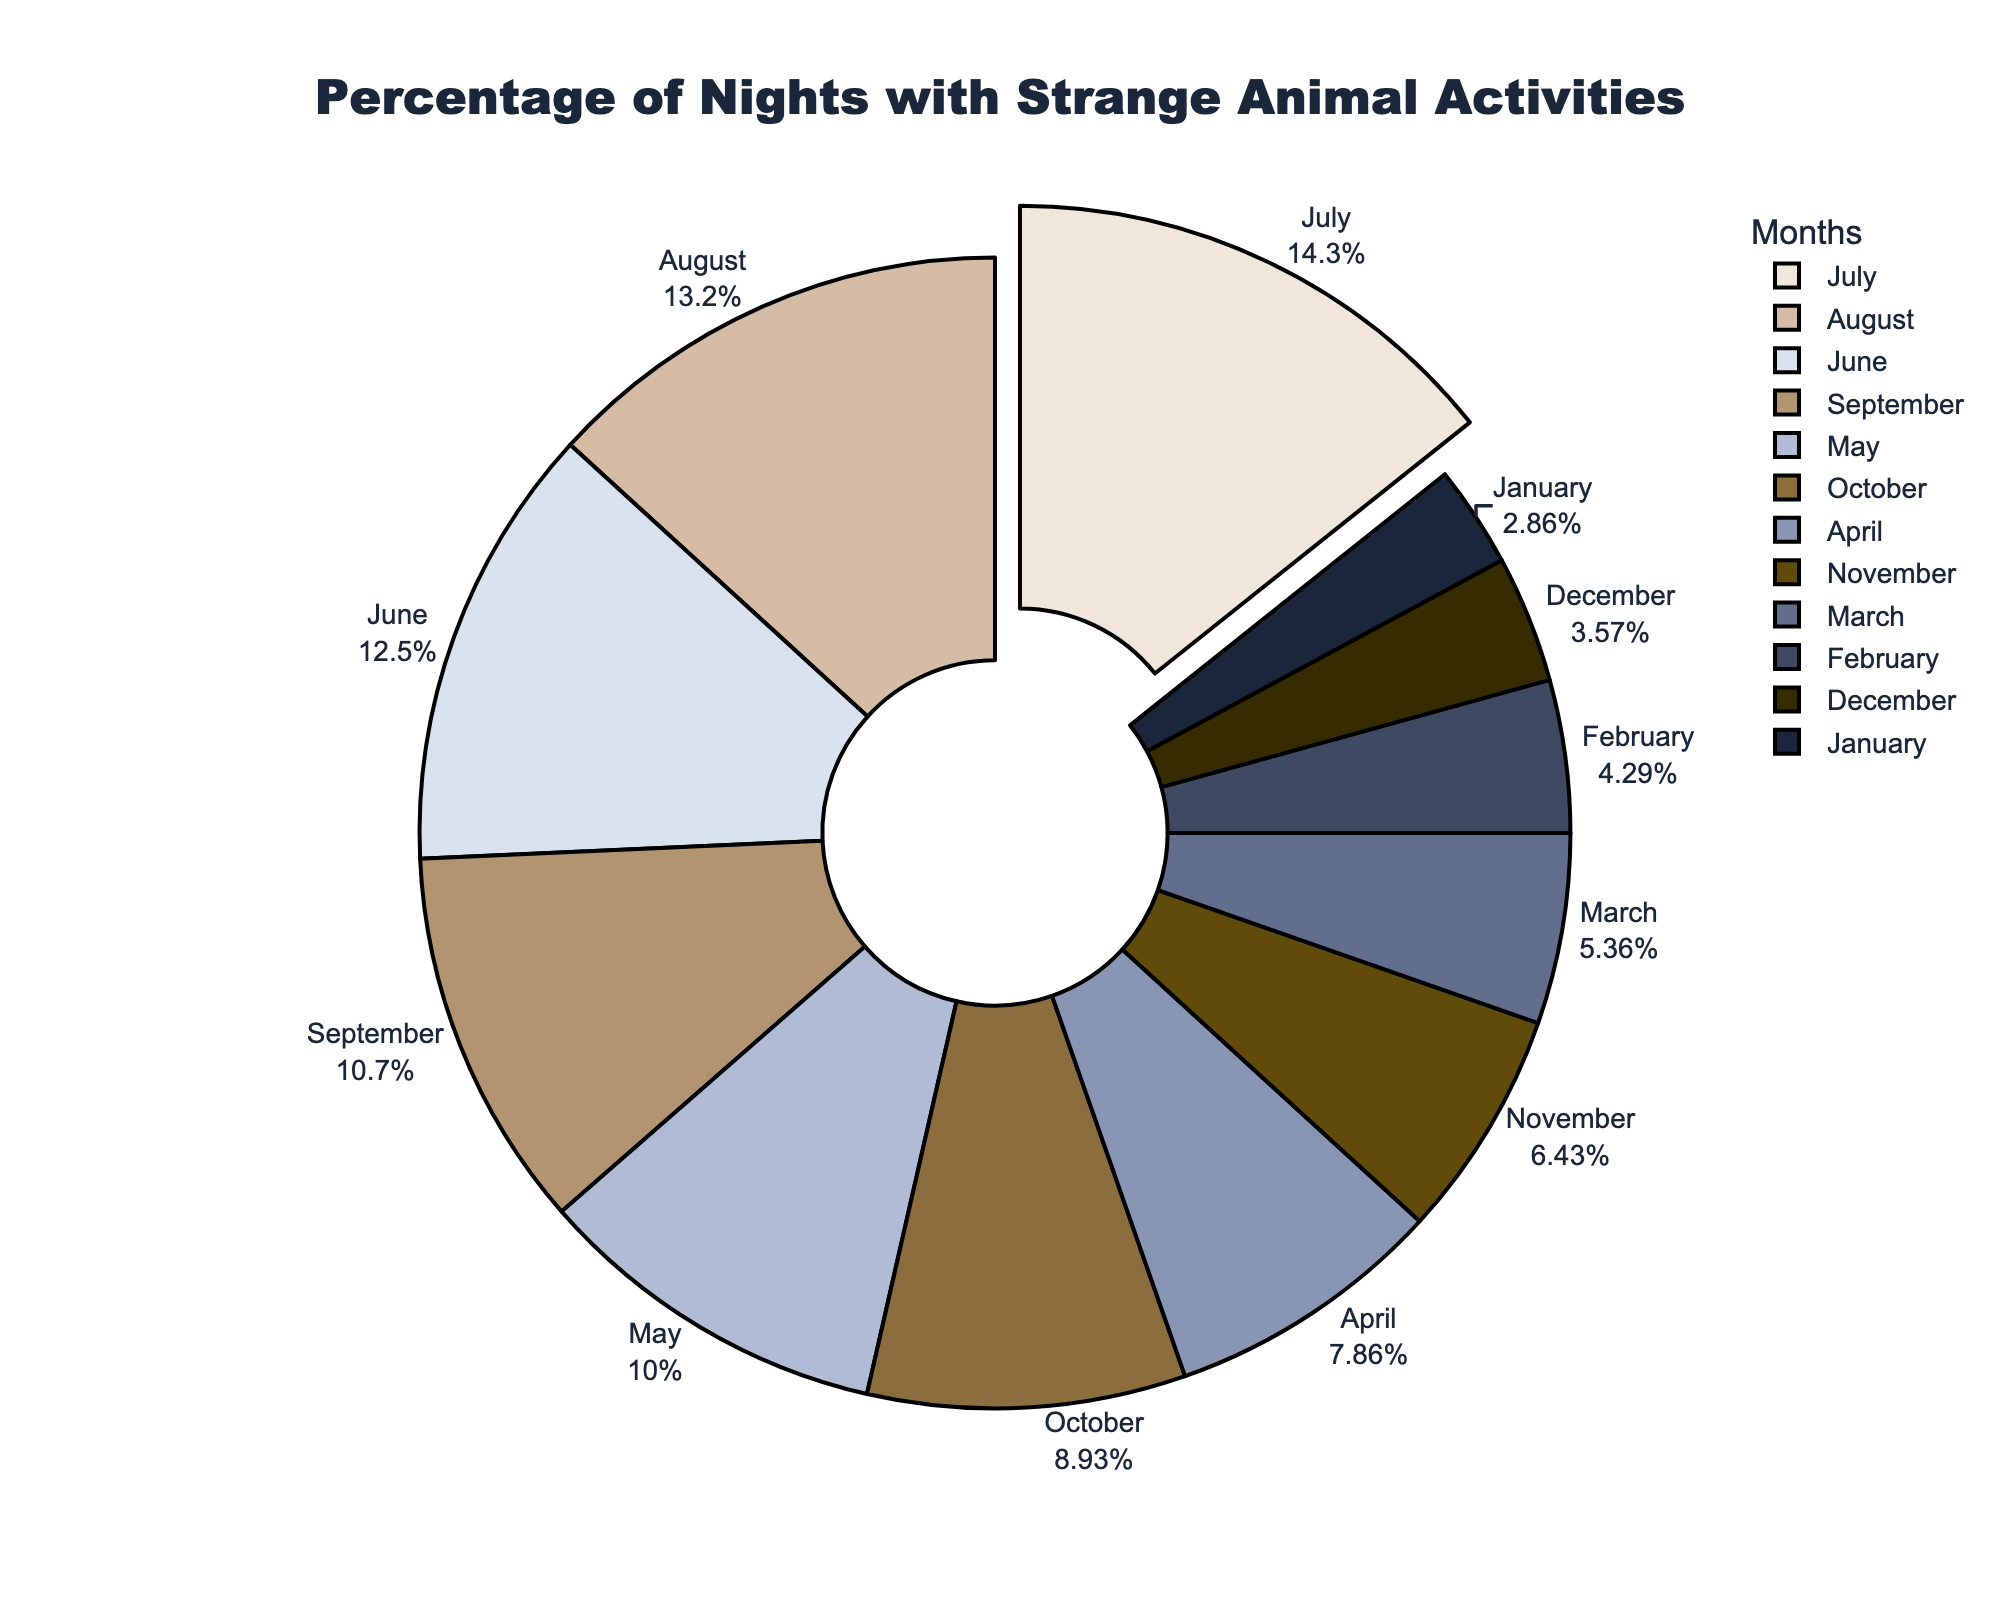Which month has the highest percentage of nights with strange animal activities? By observing the lengths of the slices, find the month with the largest slice. June has the largest slice.
Answer: June What is the difference in percentage between the months with the highest and lowest reported strange animal activities? Identify the highest and lowest slices: June (40%) and January (8%). Calculate the difference: 40% - 8% = 32%.
Answer: 32% Which quarter of the year has the highest average percentage of nights with strange animal activities? Divide the year into four quarters: 
Q1 (Jan, Feb, Mar), Q2 (Apr, May, Jun), Q3 (Jul, Aug, Sep), Q4 (Oct, Nov, Dec). Calculate the average for each:
- Q1: (8 + 12 + 15) / 3 = 11.67%
- Q2: (22 + 28 + 35) / 3 = 28.33%
- Q3: (40 + 37 + 30) / 3 = 35.67%
- Q4: (25 + 18 + 10) / 3 = 17.67%
The highest average is Q3.
Answer: Q3 How much larger is the percentage of nights with strange animal activities in May compared to October? Find the percentages for May (28%) and October (25%). Subtract October from May: 28% - 25% = 3%.
Answer: 3% What percentage of nights with strange animal activities occurred in the first half of the year? Sum the percentages for January to June: 8 + 12 + 15 + 22 + 28 + 35 = 120%.
Answer: 120% Which three consecutive months have the highest combined percentage of nights with strange animal activities? Calculate for:
- Jan-Mar: 8+12+15 = 35%
- Feb-Apr: 12+15+22 = 49%
- Mar-May: 15+22+28 = 65%
- Apr-Jun: 22+28+35 = 85%
- May-Jul: 28+35+40 = 103%
- Jun-Aug: 35+40+37 = 112%
- Jul-Sep: 40+37+30 = 107%
- Aug-Oct: 37+30+25 = 92%
- Sep-Nov: 30+25+18 = 73%
- Oct-Dec: 25+18+10 = 53%
The highest is Jun-Aug with 112%.
Answer: Jun-Aug Is the percentage of reported strange animal activities greater in December or February? Compare the slices for December (10%) and February (12%). February's slice is larger.
Answer: February How much more percentage of nights with strange animal activities are in July compared to the previous month, June? Find the percentages for July (40%) and June (35%). Subtract June from July: 40% - 35% = 5%.
Answer: 5% 